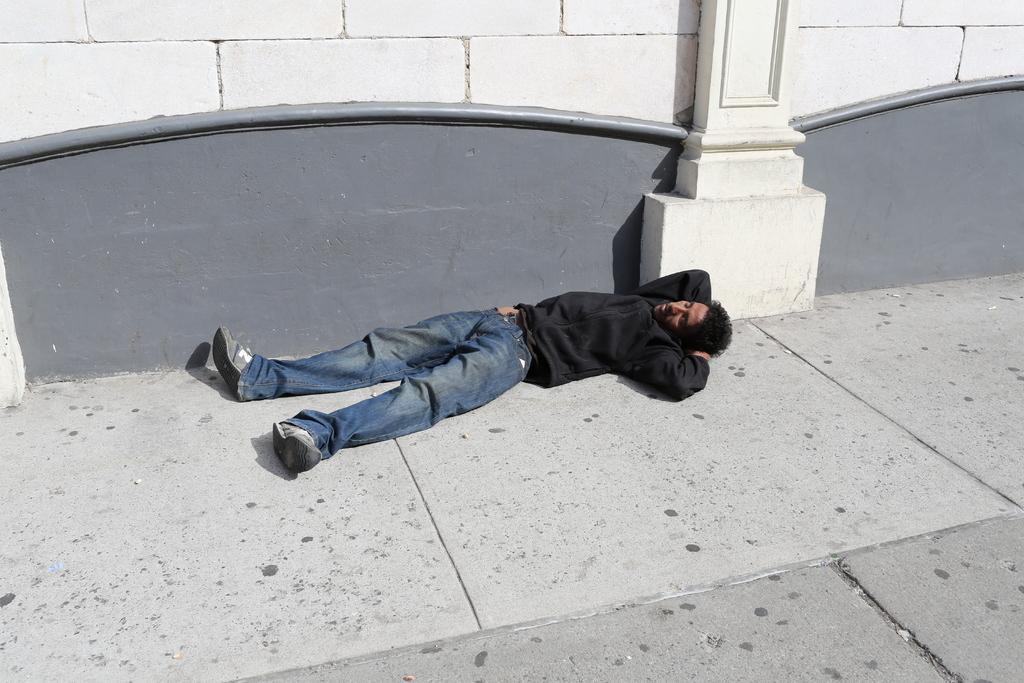Please provide a concise description of this image. In this picture we can see a man lying on the path. We can see a wall and a pillar in the background. 